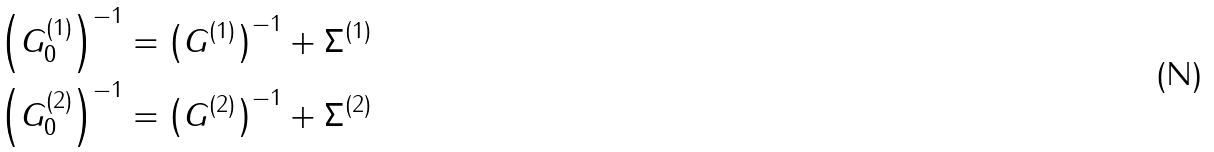<formula> <loc_0><loc_0><loc_500><loc_500>\left ( G _ { 0 } ^ { ( 1 ) } \right ) ^ { - 1 } & = \left ( G ^ { ( 1 ) } \right ) ^ { - 1 } + \Sigma ^ { ( 1 ) } \\ \left ( G _ { 0 } ^ { ( 2 ) } \right ) ^ { - 1 } & = \left ( G ^ { ( 2 ) } \right ) ^ { - 1 } + \Sigma ^ { ( 2 ) }</formula> 